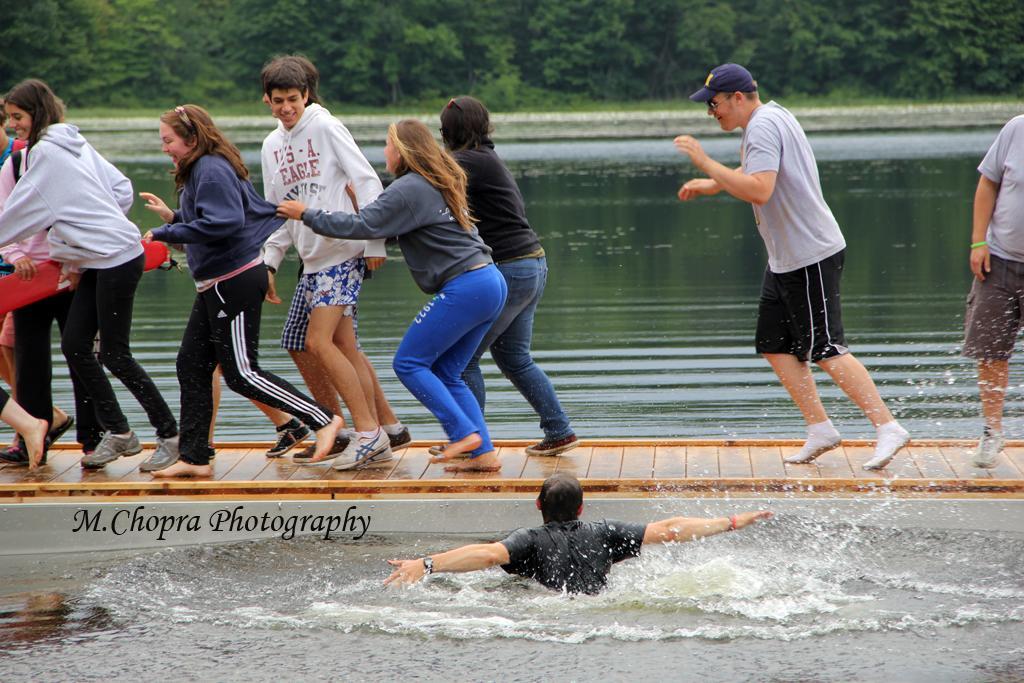Describe this image in one or two sentences. In this picture there are people walking on the surface and there is a person in the water and we can see text. In the background of the image we can see grass and trees. 